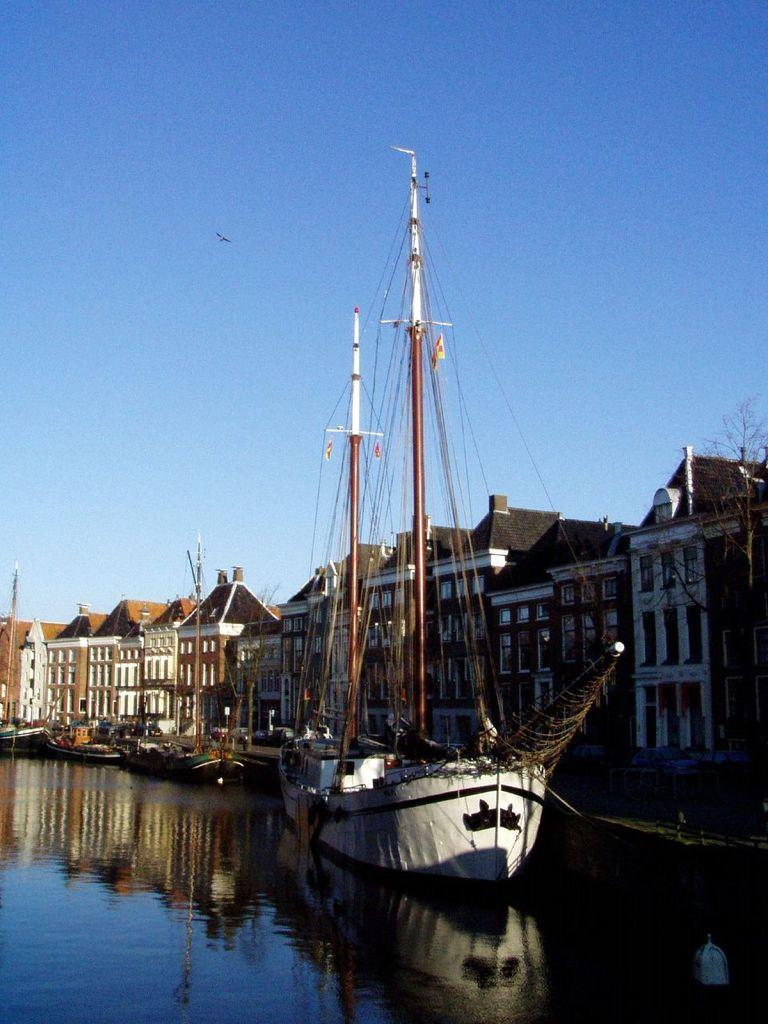What type of vehicles can be seen in the water in the image? There are ships in the water in the image. What structures are visible in the image? There are buildings visible in the image. What type of plant life is present in the image? There is a tree in the image. What animal can be seen in the sky in the image? A bird is flying in the sky in the image. What type of mark does the bird leave on the tree in the image? There is no mark left by the bird on the tree in the image, as the bird is flying and not interacting with the tree. 